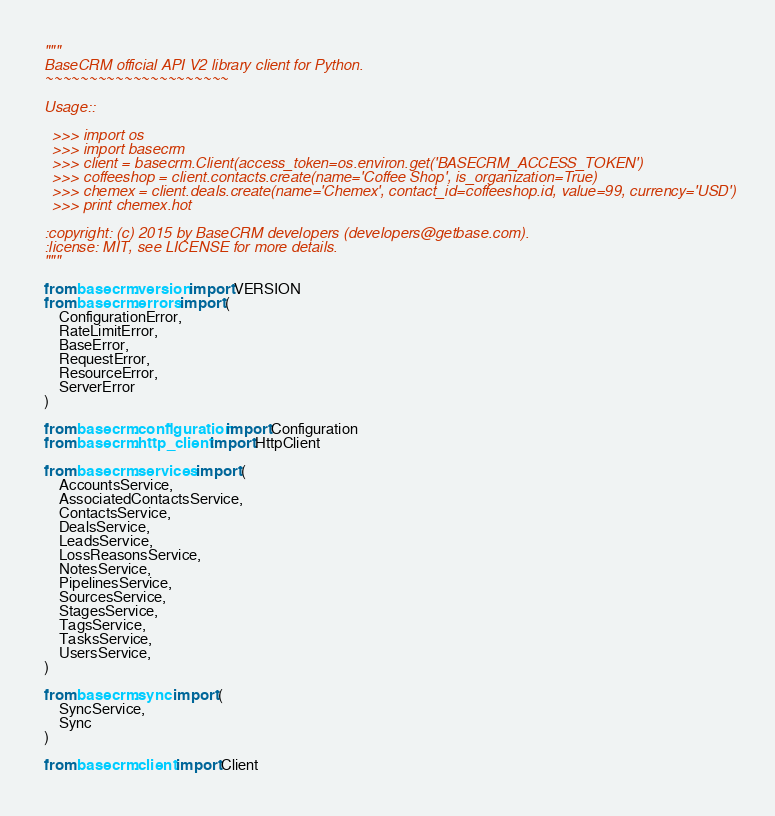Convert code to text. <code><loc_0><loc_0><loc_500><loc_500><_Python_>"""
BaseCRM official API V2 library client for Python.
~~~~~~~~~~~~~~~~~~~~~

Usage::

  >>> import os
  >>> import basecrm
  >>> client = basecrm.Client(access_token=os.environ.get('BASECRM_ACCESS_TOKEN')
  >>> coffeeshop = client.contacts.create(name='Coffee Shop', is_organization=True)
  >>> chemex = client.deals.create(name='Chemex', contact_id=coffeeshop.id, value=99, currency='USD')
  >>> print chemex.hot

:copyright: (c) 2015 by BaseCRM developers (developers@getbase.com).
:license: MIT, see LICENSE for more details.
"""

from basecrm.version import VERSION
from basecrm.errors import (
    ConfigurationError,
    RateLimitError,
    BaseError,
    RequestError,
    ResourceError,
    ServerError
)

from basecrm.configuration import Configuration
from basecrm.http_client import HttpClient

from basecrm.services import (
    AccountsService,
    AssociatedContactsService,
    ContactsService,
    DealsService,
    LeadsService,
    LossReasonsService,
    NotesService,
    PipelinesService,
    SourcesService,
    StagesService,
    TagsService,
    TasksService,
    UsersService,
)

from basecrm.sync import (
    SyncService,
    Sync
)

from basecrm.client import Client
</code> 